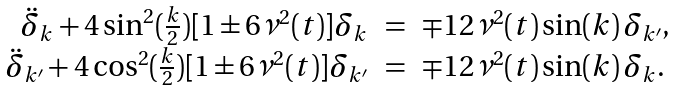<formula> <loc_0><loc_0><loc_500><loc_500>\begin{array} { r c l } \ddot { \delta } _ { k } + 4 \sin ^ { 2 } ( \frac { k } { 2 } ) [ 1 \pm 6 \nu ^ { 2 } ( t ) ] \delta _ { k } & = & \mp 1 2 \nu ^ { 2 } ( t ) \sin ( k ) \, \delta _ { k ^ { \prime } } , \\ \ddot { \delta } _ { k ^ { \prime } } + 4 \cos ^ { 2 } ( \frac { k } { 2 } ) [ 1 \pm 6 \nu ^ { 2 } ( t ) ] \delta _ { k ^ { \prime } } & = & \mp 1 2 \nu ^ { 2 } ( t ) \sin ( k ) \, \delta _ { k } . \end{array}</formula> 